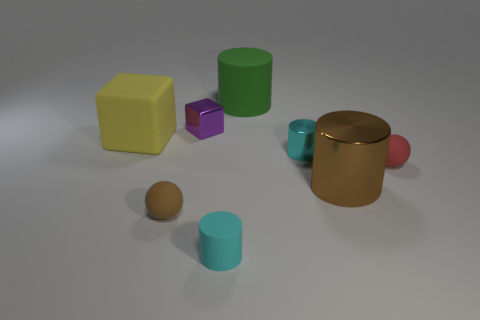What might these objects represent in a symbolic interpretation? Symbolically, these objects might represent diversity and individuality. Each object has a distinct size, shape, and color, which could be interpreted as a metaphor for the variety of traits within a group or society. The arrangement of the objects might suggest community or interaction among diverse elements. 